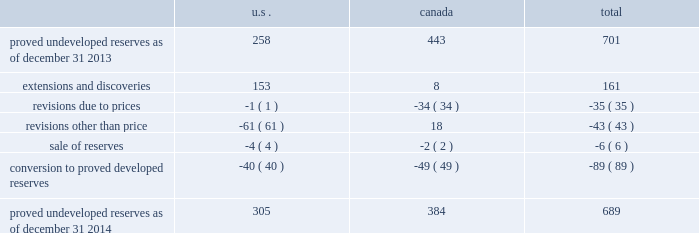Devon energy corporation and subsidiaries notes to consolidated financial statements 2013 ( continued ) proved undeveloped reserves the table presents the changes in devon 2019s total proved undeveloped reserves during 2014 ( in mmboe ) . .
At december 31 , 2014 , devon had 689 mmboe of proved undeveloped reserves .
This represents a 2 percent decrease as compared to 2013 and represents 25 percent of total proved reserves .
Drilling and development activities increased devon 2019s proved undeveloped reserves 161 mmboe and resulted in the conversion of 89 mmboe , or 13 percent , of the 2013 proved undeveloped reserves to proved developed reserves .
Costs incurred related to the development and conversion of devon 2019s proved undeveloped reserves were approximately $ 1.0 billion for 2014 .
Additionally , revisions other than price decreased devon 2019s proved undeveloped reserves 43 mmboe primarily due to evaluations of certain u.s .
Onshore dry-gas areas , which devon does not expect to develop in the next five years .
The largest revisions , which were approximately 69 mmboe , relate to the dry-gas areas in the barnett shale in north texas .
A significant amount of devon 2019s proved undeveloped reserves at the end of 2014 related to its jackfish operations .
At december 31 , 2014 and 2013 , devon 2019s jackfish proved undeveloped reserves were 384 mmboe and 441 mmboe , respectively .
Development schedules for the jackfish reserves are primarily controlled by the need to keep the processing plants at their 35000 barrel daily facility capacity .
Processing plant capacity is controlled by factors such as total steam processing capacity and steam-oil ratios .
Furthermore , development of these projects involves the up-front construction of steam injection/distribution and bitumen processing facilities .
Due to the large up-front capital investments and large reserves required to provide economic returns , the project conditions meet the specific circumstances requiring a period greater than 5 years for conversion to developed reserves .
As a result , these reserves are classified as proved undeveloped for more than five years .
Currently , the development schedule for these reserves extends though the year 2031 .
Price revisions 2014 2013 reserves increased 9 mmboe primarily due to higher gas prices in the barnett shale and the anadarko basin , partially offset by higher bitumen prices , which result in lower after-royalty volumes , in canada .
2013 2013 reserves increased 94 mmboe primarily due to higher gas prices .
Of this increase , 43 mmboe related to the barnett shale and 19 mmboe related to the rocky mountain area .
2012 2013 reserves decreased 171 mmboe primarily due to lower gas prices .
Of this decrease , 100 mmboe related to the barnett shale and 25 mmboe related to the rocky mountain area. .
As of december 31 2013 what was the percentage of the proved undeveloped reserves in the us? 
Computations: (258 / 701)
Answer: 0.36805. Devon energy corporation and subsidiaries notes to consolidated financial statements 2013 ( continued ) proved undeveloped reserves the table presents the changes in devon 2019s total proved undeveloped reserves during 2014 ( in mmboe ) . .
At december 31 , 2014 , devon had 689 mmboe of proved undeveloped reserves .
This represents a 2 percent decrease as compared to 2013 and represents 25 percent of total proved reserves .
Drilling and development activities increased devon 2019s proved undeveloped reserves 161 mmboe and resulted in the conversion of 89 mmboe , or 13 percent , of the 2013 proved undeveloped reserves to proved developed reserves .
Costs incurred related to the development and conversion of devon 2019s proved undeveloped reserves were approximately $ 1.0 billion for 2014 .
Additionally , revisions other than price decreased devon 2019s proved undeveloped reserves 43 mmboe primarily due to evaluations of certain u.s .
Onshore dry-gas areas , which devon does not expect to develop in the next five years .
The largest revisions , which were approximately 69 mmboe , relate to the dry-gas areas in the barnett shale in north texas .
A significant amount of devon 2019s proved undeveloped reserves at the end of 2014 related to its jackfish operations .
At december 31 , 2014 and 2013 , devon 2019s jackfish proved undeveloped reserves were 384 mmboe and 441 mmboe , respectively .
Development schedules for the jackfish reserves are primarily controlled by the need to keep the processing plants at their 35000 barrel daily facility capacity .
Processing plant capacity is controlled by factors such as total steam processing capacity and steam-oil ratios .
Furthermore , development of these projects involves the up-front construction of steam injection/distribution and bitumen processing facilities .
Due to the large up-front capital investments and large reserves required to provide economic returns , the project conditions meet the specific circumstances requiring a period greater than 5 years for conversion to developed reserves .
As a result , these reserves are classified as proved undeveloped for more than five years .
Currently , the development schedule for these reserves extends though the year 2031 .
Price revisions 2014 2013 reserves increased 9 mmboe primarily due to higher gas prices in the barnett shale and the anadarko basin , partially offset by higher bitumen prices , which result in lower after-royalty volumes , in canada .
2013 2013 reserves increased 94 mmboe primarily due to higher gas prices .
Of this increase , 43 mmboe related to the barnett shale and 19 mmboe related to the rocky mountain area .
2012 2013 reserves decreased 171 mmboe primarily due to lower gas prices .
Of this decrease , 100 mmboe related to the barnett shale and 25 mmboe related to the rocky mountain area. .
What was the percentage reduction of the proved undeveloped reserves from 2013 to 2014? 
Computations: ((689 - 701) / 701)
Answer: -0.01712. 